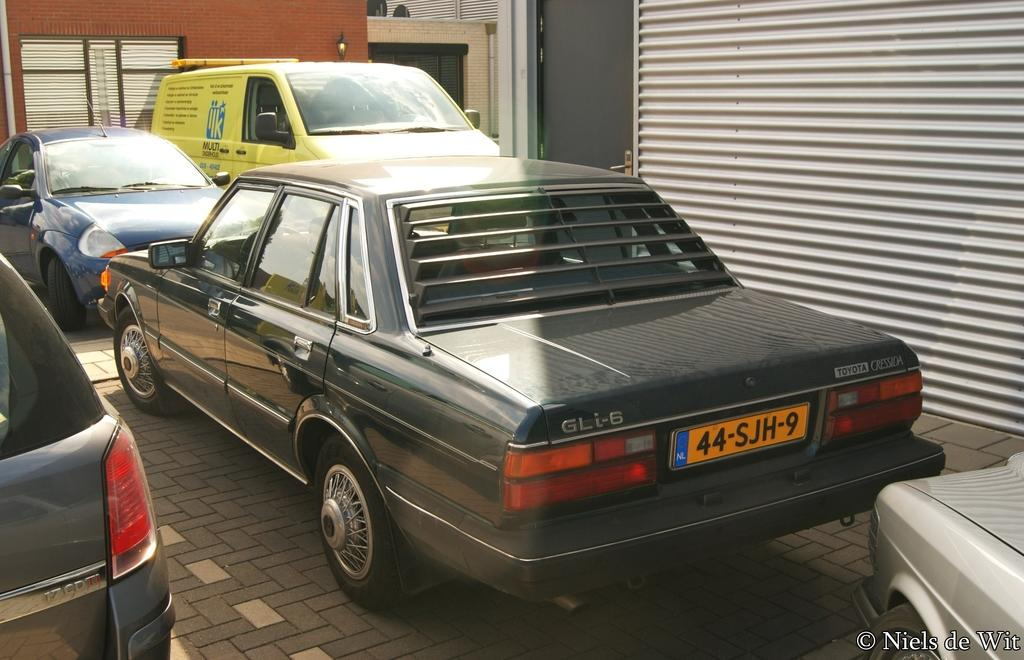What types of objects can be seen in the image? There are vehicles and buildings in the image. Can you describe the vehicles in the image? The provided facts do not give specific details about the vehicles, so we cannot describe them further. What can be said about the buildings in the image? The provided facts do not give specific details about the buildings, so we cannot describe them further. What type of berry is being served by the secretary in the image? There is no secretary or berry present in the image. 